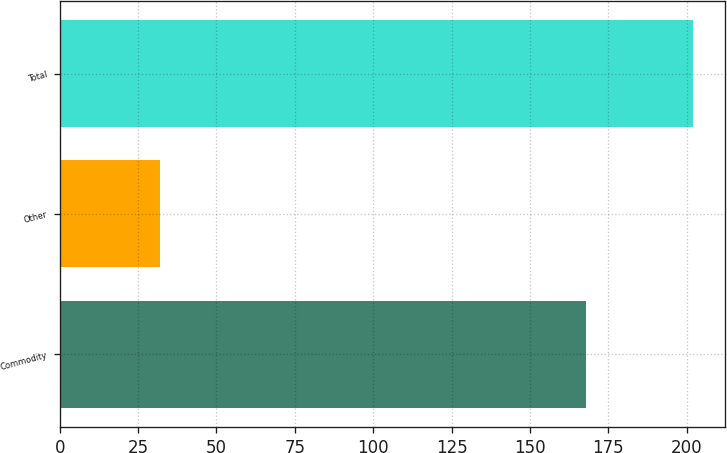Convert chart to OTSL. <chart><loc_0><loc_0><loc_500><loc_500><bar_chart><fcel>Commodity<fcel>Other<fcel>Total<nl><fcel>168<fcel>32<fcel>202<nl></chart> 